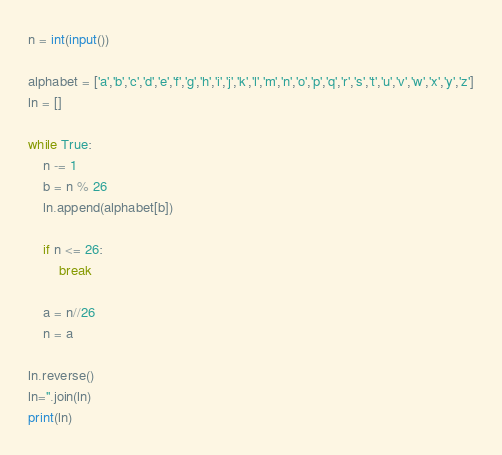Convert code to text. <code><loc_0><loc_0><loc_500><loc_500><_Python_>n = int(input())

alphabet = ['a','b','c','d','e','f','g','h','i','j','k','l','m','n','o','p','q','r','s','t','u','v','w','x','y','z']
ln = []

while True:
    n -= 1
    b = n % 26
    ln.append(alphabet[b])

    if n <= 26:
        break

    a = n//26
    n = a

ln.reverse()
ln=''.join(ln)
print(ln)</code> 